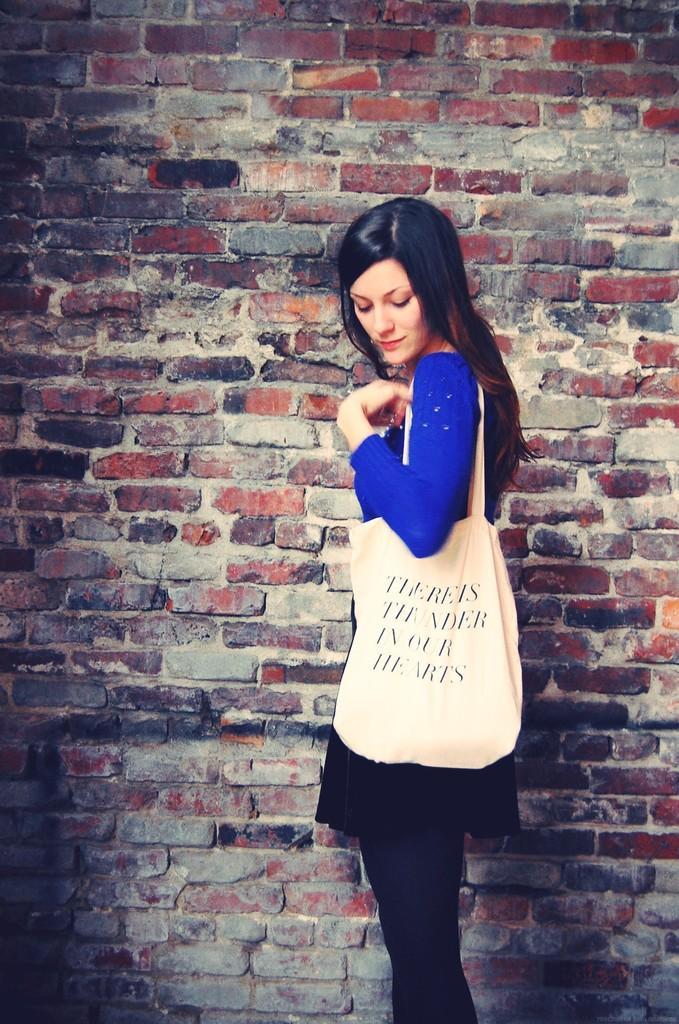Describe this image in one or two sentences. In this image we can see a woman wearing a bag standing beside a wall. 